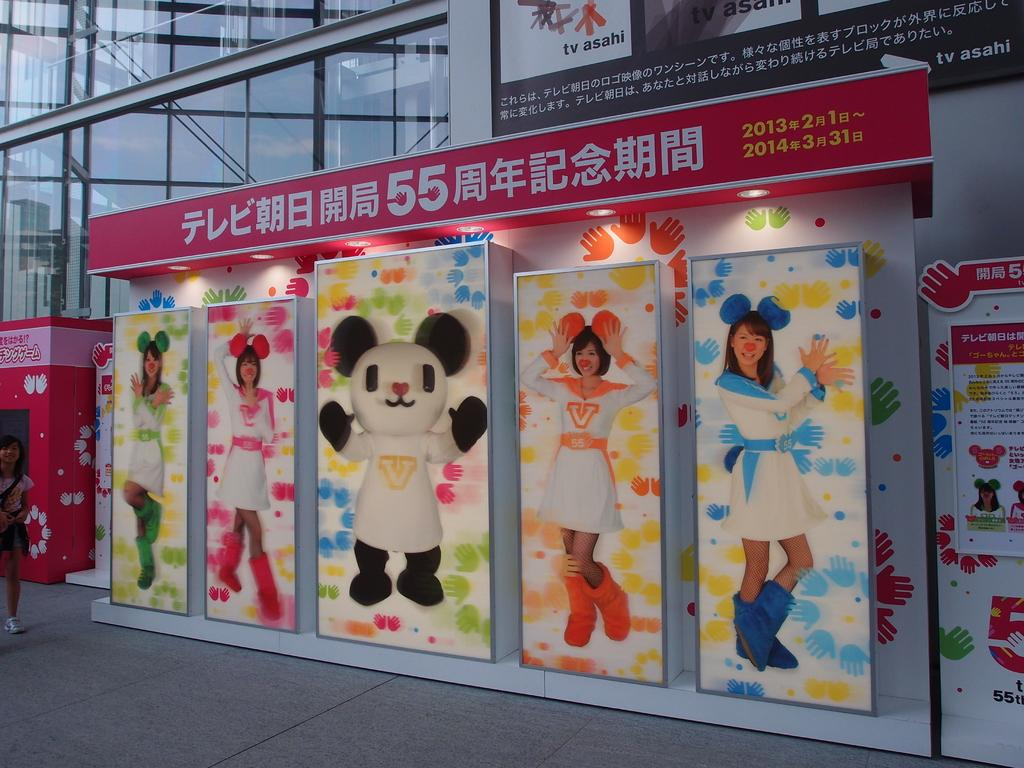What type of structure is visible in the image? There is a building in the image. What is placed in front of the building? There are banners in front of the building. Are there any people or figures depicted in the image? Yes, there are images of a person in the image. Can you describe the lady's position in the image? A lady is standing on the floor in the image. What type of drug is being sold at the railway station in the image? There is no railway station or drug sale depicted in the image. 